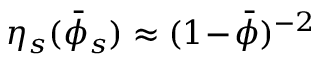Convert formula to latex. <formula><loc_0><loc_0><loc_500><loc_500>\eta _ { s } ( \bar { \phi } _ { s } ) \approx ( 1 \, - \, \bar { \phi } ) ^ { - 2 }</formula> 